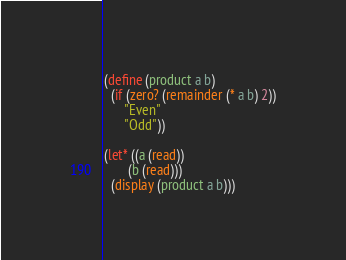Convert code to text. <code><loc_0><loc_0><loc_500><loc_500><_Scheme_>(define (product a b)
  (if (zero? (remainder (* a b) 2))
      "Even"
      "Odd"))

(let* ((a (read))
       (b (read)))
  (display (product a b)))
</code> 